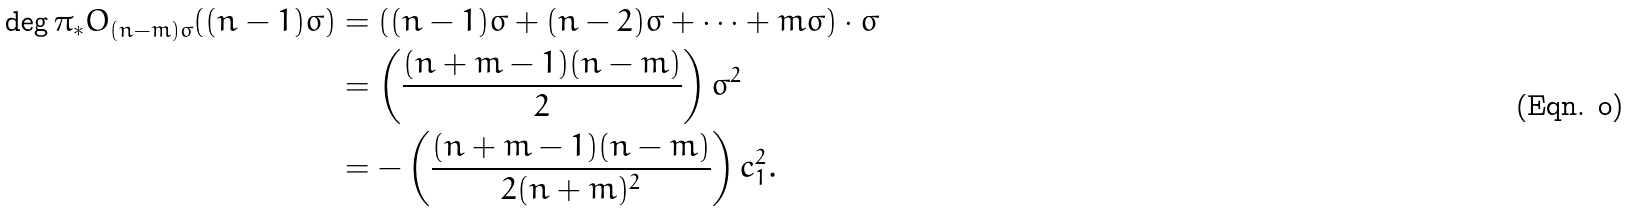<formula> <loc_0><loc_0><loc_500><loc_500>\deg \pi _ { * } O _ { ( n - m ) \sigma } ( ( n - 1 ) \sigma ) & = \left ( ( n - 1 ) \sigma + ( n - 2 ) \sigma + \dots + m \sigma \right ) \cdot \sigma \\ & = \left ( \frac { ( n + m - 1 ) ( n - m ) } { 2 } \right ) \sigma ^ { 2 } \\ & = - \left ( \frac { ( n + m - 1 ) ( n - m ) } { 2 ( n + m ) ^ { 2 } } \right ) c _ { 1 } ^ { 2 } .</formula> 